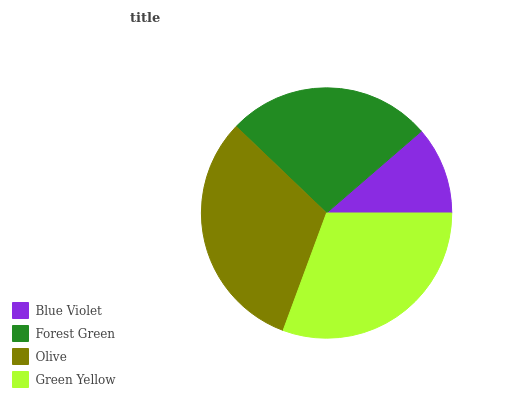Is Blue Violet the minimum?
Answer yes or no. Yes. Is Olive the maximum?
Answer yes or no. Yes. Is Forest Green the minimum?
Answer yes or no. No. Is Forest Green the maximum?
Answer yes or no. No. Is Forest Green greater than Blue Violet?
Answer yes or no. Yes. Is Blue Violet less than Forest Green?
Answer yes or no. Yes. Is Blue Violet greater than Forest Green?
Answer yes or no. No. Is Forest Green less than Blue Violet?
Answer yes or no. No. Is Green Yellow the high median?
Answer yes or no. Yes. Is Forest Green the low median?
Answer yes or no. Yes. Is Forest Green the high median?
Answer yes or no. No. Is Blue Violet the low median?
Answer yes or no. No. 